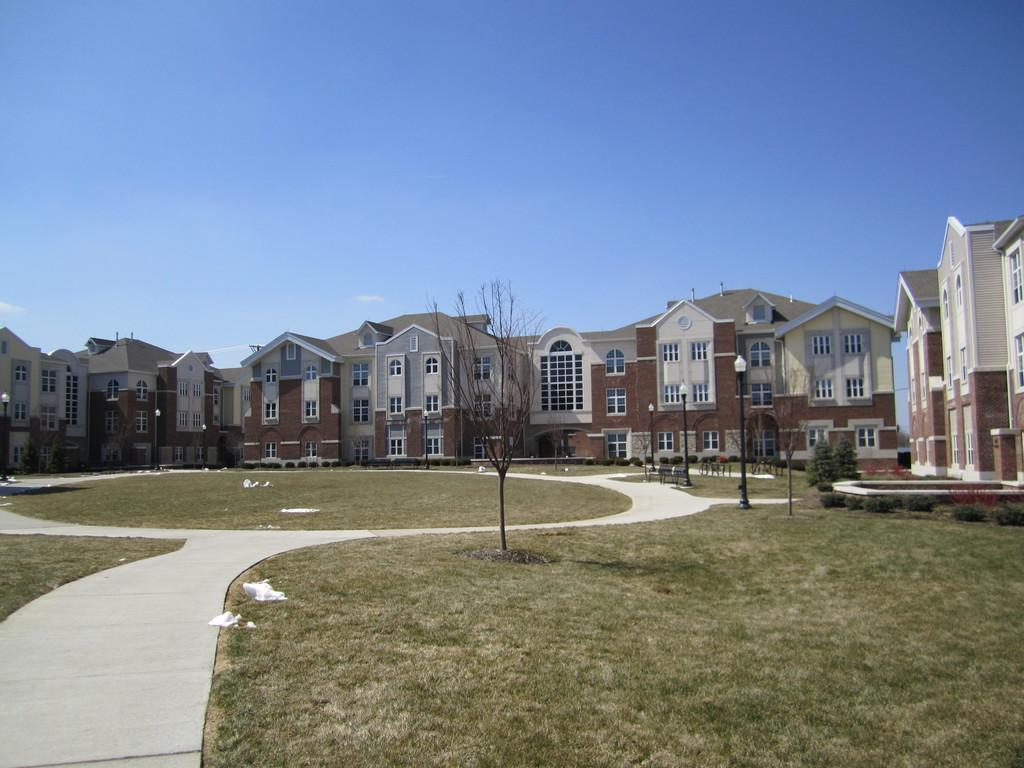What type of structures can be seen in the image? There are buildings in the image. What other natural elements are present in the image? There are trees in the image. What are the vertical structures in the image used for? The poles in the image are likely used for support or as markers. What can be seen at the bottom of the image? The ground is visible at the bottom of the image. What is visible at the top of the image? The sky is visible at the top of the image. What word is being used to describe the news in the image? There is no news or word present in the image; it features buildings, trees, poles, ground, and sky. What need is being addressed by the buildings in the image? The image does not provide information about the specific needs being addressed by the buildings; it simply shows their presence. 